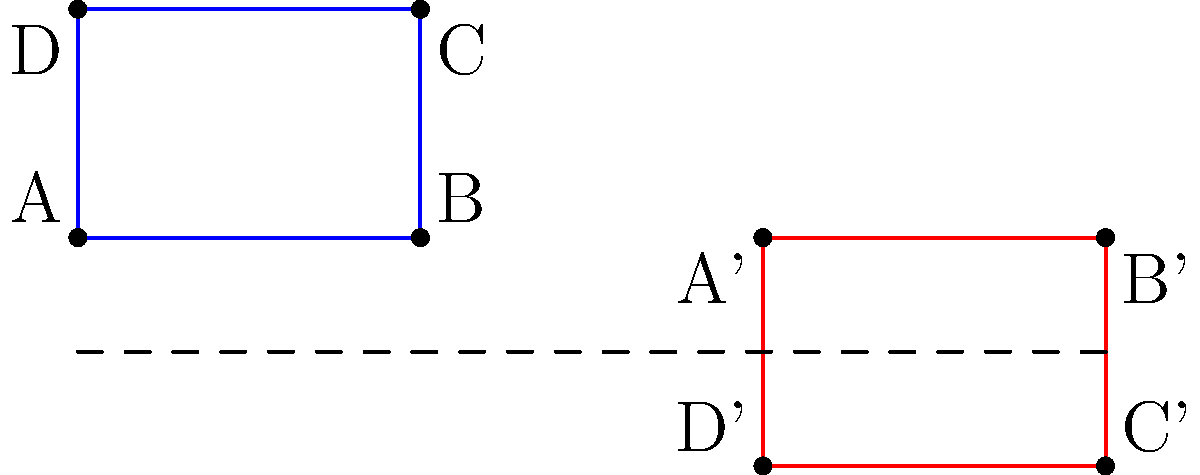A resistance band loop is represented by the blue rectangle ABCD. After a glide reflection, it transforms into the red rectangle A'B'C'D'. What is the glide vector of this transformation? To find the glide vector, we need to follow these steps:

1. Identify the line of reflection:
   The dashed line y = -1 is the line of reflection.

2. Observe the horizontal shift:
   The original shape moves 6 units to the right.

3. Analyze the vertical reflection:
   Points are reflected across the line y = -1.

4. Determine the glide vector:
   - Horizontal component: 6 units right
   - Vertical component: 0 (no vertical shift after reflection)

Therefore, the glide vector is $\vec{v} = (6, 0)$.

Note: In a glide reflection, the shape is first reflected over a line and then translated parallel to that line. The glide vector represents this translation.
Answer: $(6, 0)$ 